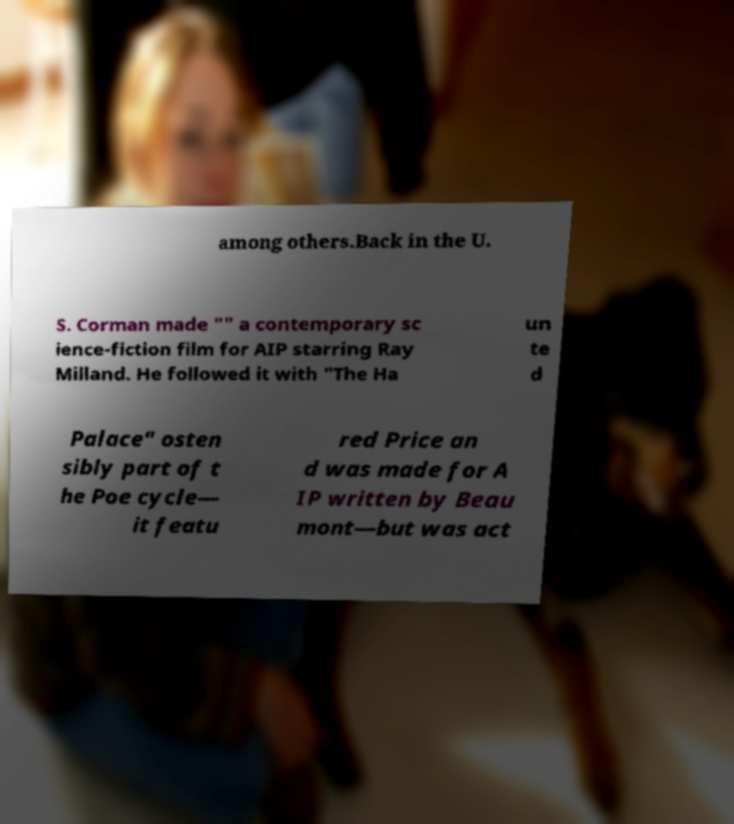Can you read and provide the text displayed in the image?This photo seems to have some interesting text. Can you extract and type it out for me? among others.Back in the U. S. Corman made "" a contemporary sc ience-fiction film for AIP starring Ray Milland. He followed it with "The Ha un te d Palace" osten sibly part of t he Poe cycle— it featu red Price an d was made for A IP written by Beau mont—but was act 